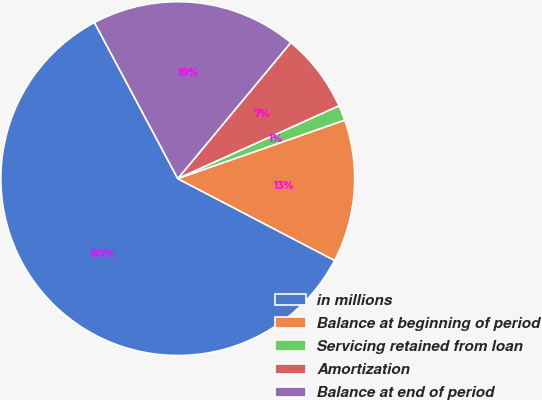Convert chart to OTSL. <chart><loc_0><loc_0><loc_500><loc_500><pie_chart><fcel>in millions<fcel>Balance at beginning of period<fcel>Servicing retained from loan<fcel>Amortization<fcel>Balance at end of period<nl><fcel>59.54%<fcel>13.02%<fcel>1.39%<fcel>7.21%<fcel>18.84%<nl></chart> 